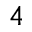Convert formula to latex. <formula><loc_0><loc_0><loc_500><loc_500>4</formula> 